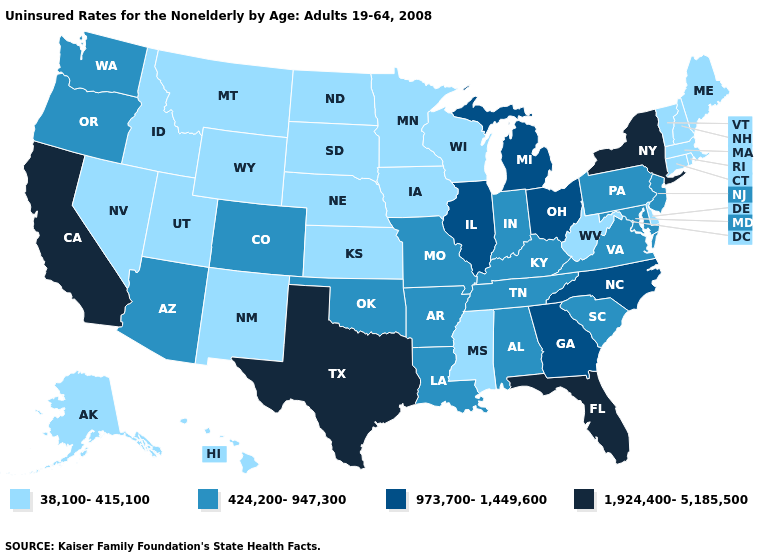Is the legend a continuous bar?
Be succinct. No. Does Kansas have the highest value in the USA?
Be succinct. No. Name the states that have a value in the range 973,700-1,449,600?
Answer briefly. Georgia, Illinois, Michigan, North Carolina, Ohio. Name the states that have a value in the range 1,924,400-5,185,500?
Short answer required. California, Florida, New York, Texas. Does Indiana have a higher value than Pennsylvania?
Be succinct. No. What is the lowest value in states that border New Hampshire?
Short answer required. 38,100-415,100. What is the lowest value in states that border Arizona?
Quick response, please. 38,100-415,100. What is the value of Iowa?
Short answer required. 38,100-415,100. Does New Hampshire have a lower value than Nevada?
Keep it brief. No. What is the lowest value in states that border West Virginia?
Write a very short answer. 424,200-947,300. Does Oregon have the same value as Idaho?
Short answer required. No. Name the states that have a value in the range 1,924,400-5,185,500?
Short answer required. California, Florida, New York, Texas. What is the value of Massachusetts?
Give a very brief answer. 38,100-415,100. Does the first symbol in the legend represent the smallest category?
Write a very short answer. Yes. Which states hav the highest value in the West?
Short answer required. California. 